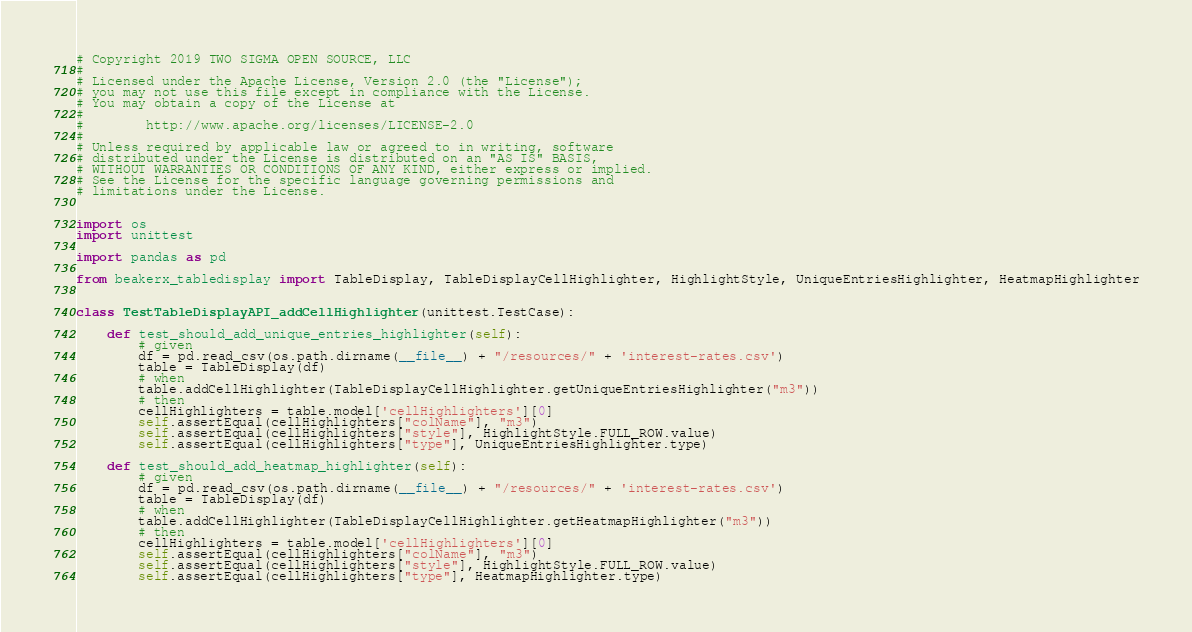<code> <loc_0><loc_0><loc_500><loc_500><_Python_># Copyright 2019 TWO SIGMA OPEN SOURCE, LLC
#
# Licensed under the Apache License, Version 2.0 (the "License");
# you may not use this file except in compliance with the License.
# You may obtain a copy of the License at
#
#        http://www.apache.org/licenses/LICENSE-2.0
#
# Unless required by applicable law or agreed to in writing, software
# distributed under the License is distributed on an "AS IS" BASIS,
# WITHOUT WARRANTIES OR CONDITIONS OF ANY KIND, either express or implied.
# See the License for the specific language governing permissions and
# limitations under the License.


import os
import unittest

import pandas as pd

from beakerx_tabledisplay import TableDisplay, TableDisplayCellHighlighter, HighlightStyle, UniqueEntriesHighlighter, HeatmapHighlighter


class TestTableDisplayAPI_addCellHighlighter(unittest.TestCase):

    def test_should_add_unique_entries_highlighter(self):
        # given
        df = pd.read_csv(os.path.dirname(__file__) + "/resources/" + 'interest-rates.csv')
        table = TableDisplay(df)
        # when
        table.addCellHighlighter(TableDisplayCellHighlighter.getUniqueEntriesHighlighter("m3"))
        # then
        cellHighlighters = table.model['cellHighlighters'][0]
        self.assertEqual(cellHighlighters["colName"], "m3")
        self.assertEqual(cellHighlighters["style"], HighlightStyle.FULL_ROW.value)
        self.assertEqual(cellHighlighters["type"], UniqueEntriesHighlighter.type)

    def test_should_add_heatmap_highlighter(self):
        # given
        df = pd.read_csv(os.path.dirname(__file__) + "/resources/" + 'interest-rates.csv')
        table = TableDisplay(df)
        # when
        table.addCellHighlighter(TableDisplayCellHighlighter.getHeatmapHighlighter("m3"))
        # then
        cellHighlighters = table.model['cellHighlighters'][0]
        self.assertEqual(cellHighlighters["colName"], "m3")
        self.assertEqual(cellHighlighters["style"], HighlightStyle.FULL_ROW.value)
        self.assertEqual(cellHighlighters["type"], HeatmapHighlighter.type)
</code> 